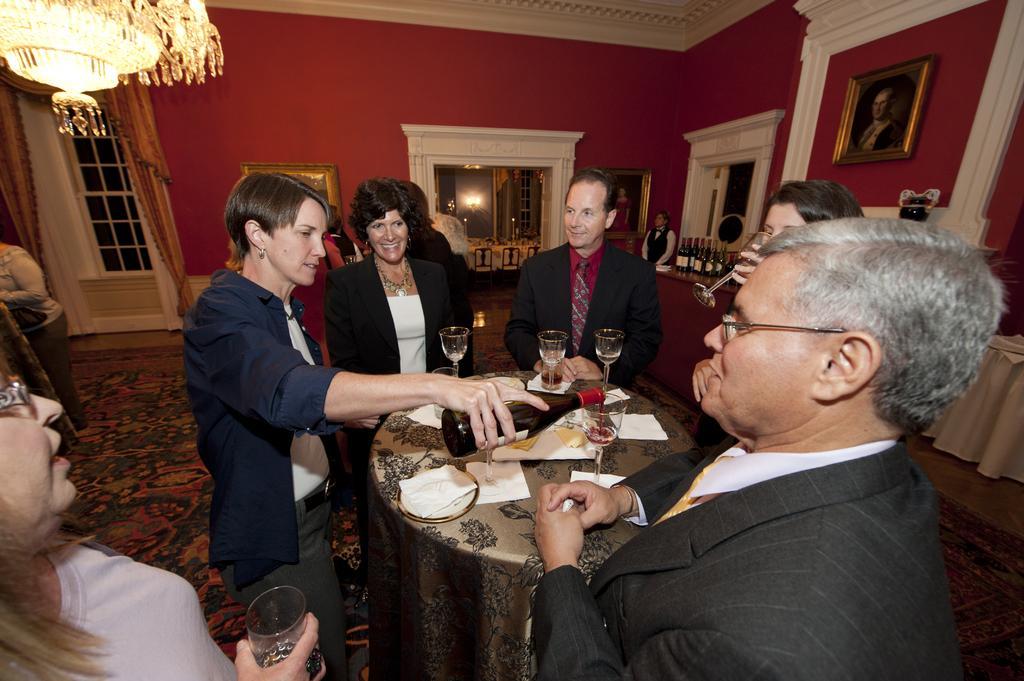Please provide a concise description of this image. In this image we can see many people. One person is holding a bottle. One lady is wearing specs and holding a glass. There is a table. On the table there are glasses, tissues and some other items. On the top there is a chandelier. In the back there is a wall with photo frames. Also there is a window with curtains. In the background there is light. There are chairs. Also there are bottles. 